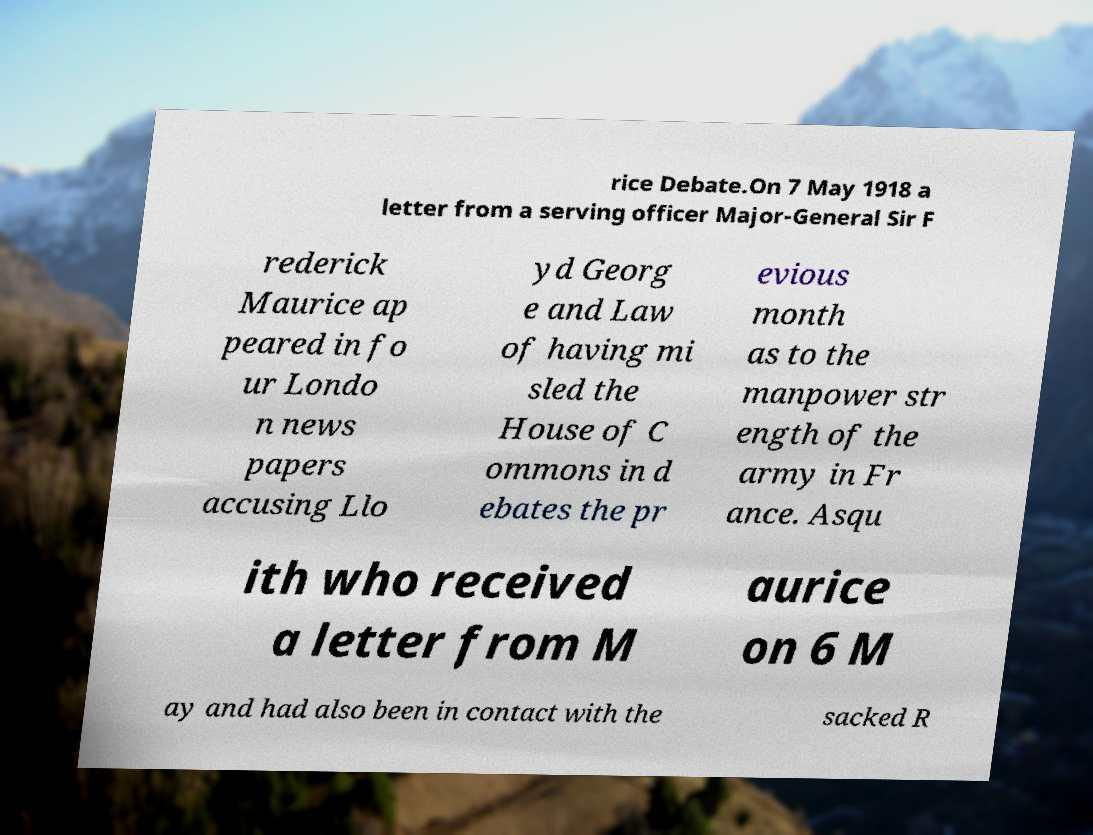Can you read and provide the text displayed in the image?This photo seems to have some interesting text. Can you extract and type it out for me? rice Debate.On 7 May 1918 a letter from a serving officer Major-General Sir F rederick Maurice ap peared in fo ur Londo n news papers accusing Llo yd Georg e and Law of having mi sled the House of C ommons in d ebates the pr evious month as to the manpower str ength of the army in Fr ance. Asqu ith who received a letter from M aurice on 6 M ay and had also been in contact with the sacked R 